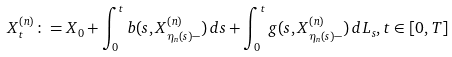Convert formula to latex. <formula><loc_0><loc_0><loc_500><loc_500>X _ { t } ^ { ( n ) } \colon = X _ { 0 } + \int _ { 0 } ^ { t } b ( s , X _ { \eta _ { n } ( s ) - } ^ { ( n ) } ) \, d s + \int _ { 0 } ^ { t } g ( s , X _ { \eta _ { n } ( s ) - } ^ { ( n ) } ) \, d L _ { s } , t \in [ 0 , T ]</formula> 